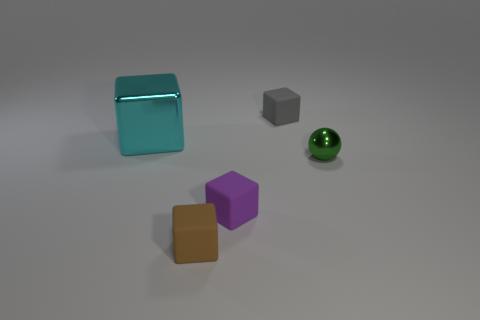Is there any other thing of the same color as the small sphere?
Your response must be concise. No. There is a rubber block that is behind the cyan block; how big is it?
Ensure brevity in your answer.  Small. Are there more yellow matte things than green balls?
Your answer should be very brief. No. What is the material of the tiny gray block?
Give a very brief answer. Rubber. How many other objects are the same material as the green sphere?
Ensure brevity in your answer.  1. How many small gray things are there?
Provide a short and direct response. 1. What is the material of the big cyan object that is the same shape as the small purple rubber thing?
Your response must be concise. Metal. Are the small cube behind the tiny metal object and the big thing made of the same material?
Provide a short and direct response. No. Are there more small objects that are behind the brown block than metallic cubes that are on the left side of the cyan shiny block?
Ensure brevity in your answer.  Yes. How big is the cyan object?
Ensure brevity in your answer.  Large. 